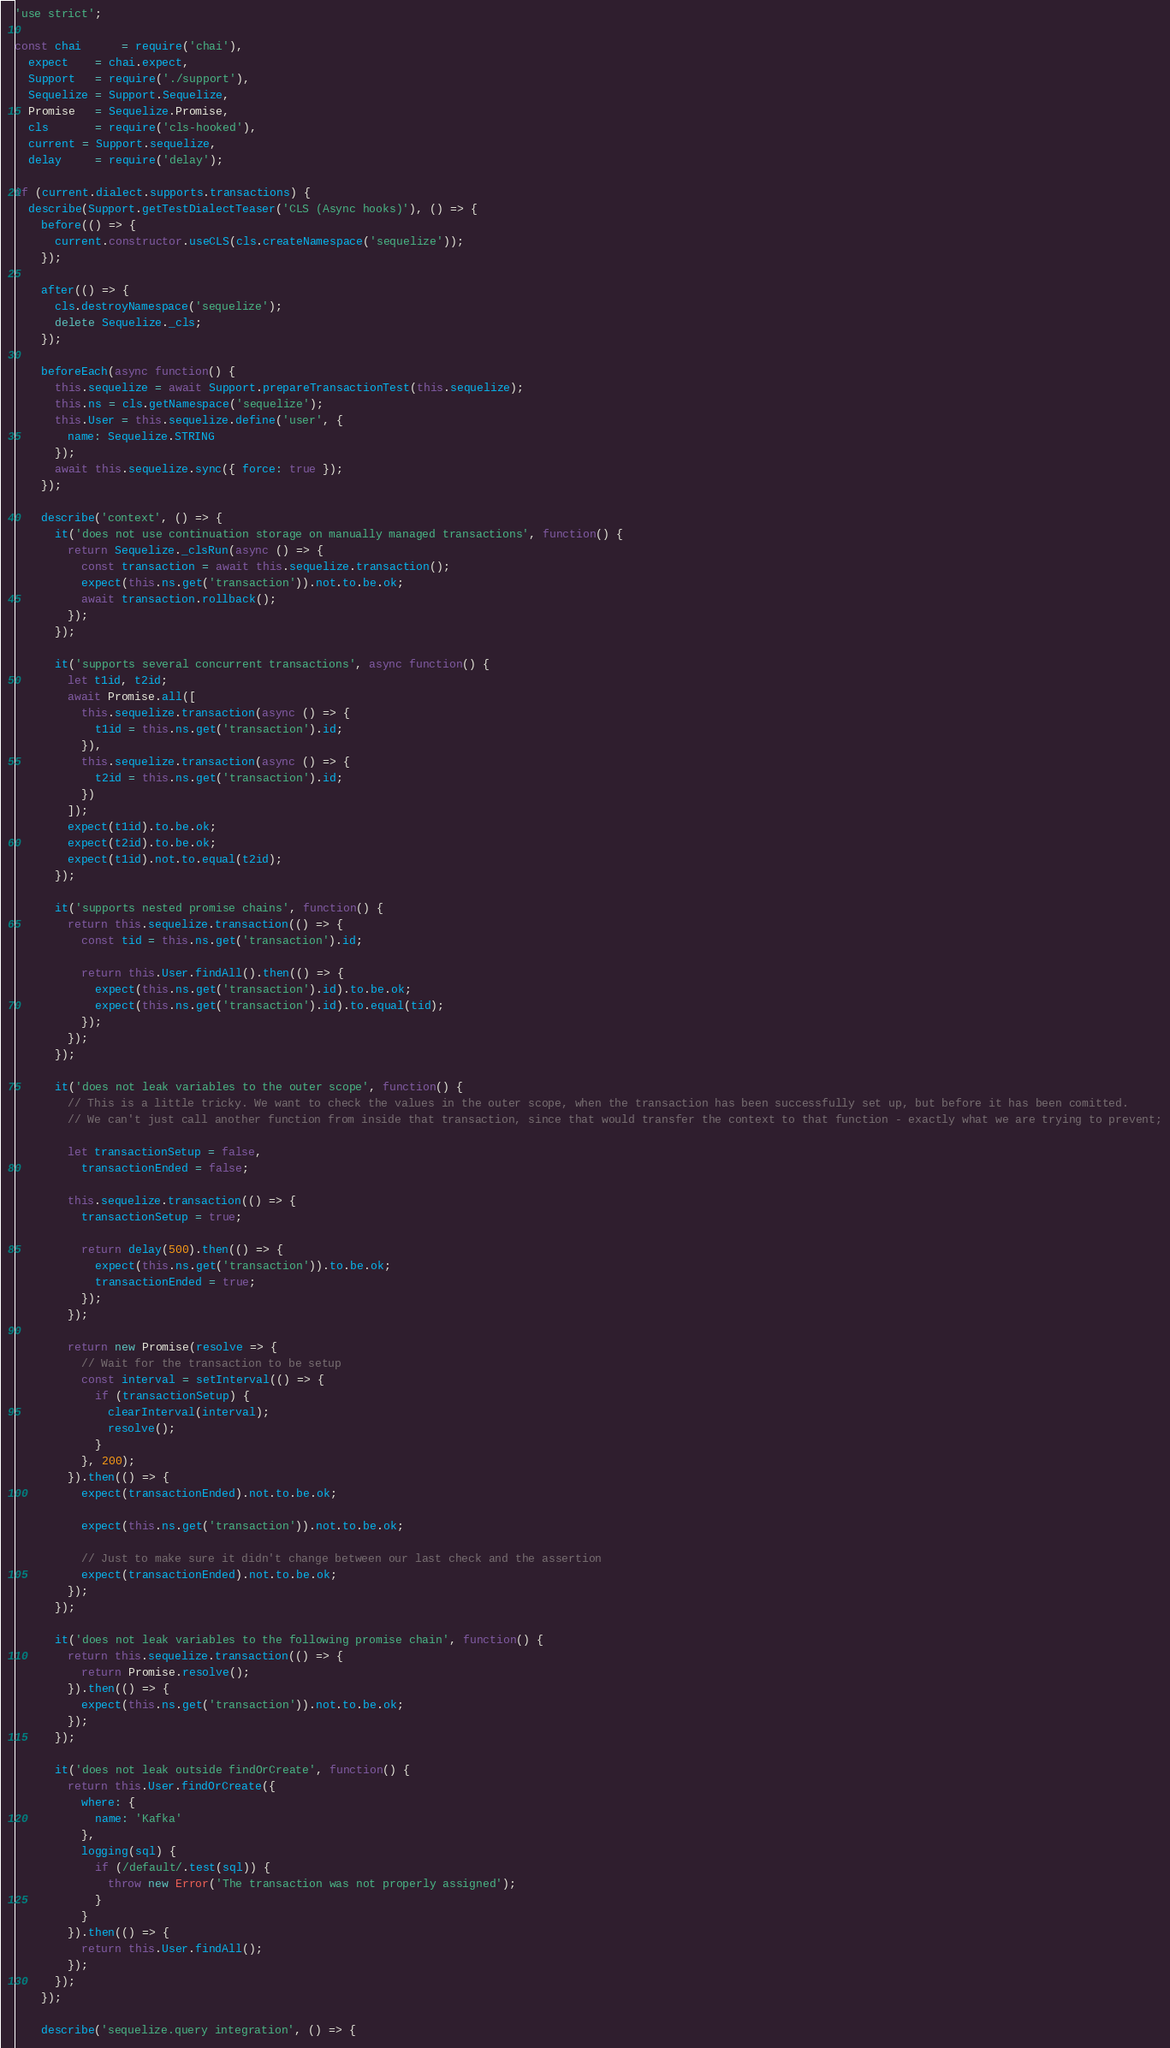<code> <loc_0><loc_0><loc_500><loc_500><_JavaScript_>'use strict';

const chai      = require('chai'),
  expect    = chai.expect,
  Support   = require('./support'),
  Sequelize = Support.Sequelize,
  Promise   = Sequelize.Promise,
  cls       = require('cls-hooked'),
  current = Support.sequelize,
  delay     = require('delay');

if (current.dialect.supports.transactions) {
  describe(Support.getTestDialectTeaser('CLS (Async hooks)'), () => {
    before(() => {
      current.constructor.useCLS(cls.createNamespace('sequelize'));
    });

    after(() => {
      cls.destroyNamespace('sequelize');
      delete Sequelize._cls;
    });

    beforeEach(async function() {
      this.sequelize = await Support.prepareTransactionTest(this.sequelize);
      this.ns = cls.getNamespace('sequelize');
      this.User = this.sequelize.define('user', {
        name: Sequelize.STRING
      });
      await this.sequelize.sync({ force: true });
    });

    describe('context', () => {
      it('does not use continuation storage on manually managed transactions', function() {
        return Sequelize._clsRun(async () => {
          const transaction = await this.sequelize.transaction();
          expect(this.ns.get('transaction')).not.to.be.ok;
          await transaction.rollback();
        });
      });

      it('supports several concurrent transactions', async function() {
        let t1id, t2id;
        await Promise.all([
          this.sequelize.transaction(async () => {
            t1id = this.ns.get('transaction').id;
          }),
          this.sequelize.transaction(async () => {
            t2id = this.ns.get('transaction').id;
          })
        ]);
        expect(t1id).to.be.ok;
        expect(t2id).to.be.ok;
        expect(t1id).not.to.equal(t2id);
      });

      it('supports nested promise chains', function() {
        return this.sequelize.transaction(() => {
          const tid = this.ns.get('transaction').id;

          return this.User.findAll().then(() => {
            expect(this.ns.get('transaction').id).to.be.ok;
            expect(this.ns.get('transaction').id).to.equal(tid);
          });
        });
      });

      it('does not leak variables to the outer scope', function() {
        // This is a little tricky. We want to check the values in the outer scope, when the transaction has been successfully set up, but before it has been comitted.
        // We can't just call another function from inside that transaction, since that would transfer the context to that function - exactly what we are trying to prevent;

        let transactionSetup = false,
          transactionEnded = false;

        this.sequelize.transaction(() => {
          transactionSetup = true;

          return delay(500).then(() => {
            expect(this.ns.get('transaction')).to.be.ok;
            transactionEnded = true;
          });
        });

        return new Promise(resolve => {
          // Wait for the transaction to be setup
          const interval = setInterval(() => {
            if (transactionSetup) {
              clearInterval(interval);
              resolve();
            }
          }, 200);
        }).then(() => {
          expect(transactionEnded).not.to.be.ok;

          expect(this.ns.get('transaction')).not.to.be.ok;

          // Just to make sure it didn't change between our last check and the assertion
          expect(transactionEnded).not.to.be.ok;
        });
      });

      it('does not leak variables to the following promise chain', function() {
        return this.sequelize.transaction(() => {
          return Promise.resolve();
        }).then(() => {
          expect(this.ns.get('transaction')).not.to.be.ok;
        });
      });

      it('does not leak outside findOrCreate', function() {
        return this.User.findOrCreate({
          where: {
            name: 'Kafka'
          },
          logging(sql) {
            if (/default/.test(sql)) {
              throw new Error('The transaction was not properly assigned');
            }
          }
        }).then(() => {
          return this.User.findAll();
        });
      });
    });

    describe('sequelize.query integration', () => {</code> 